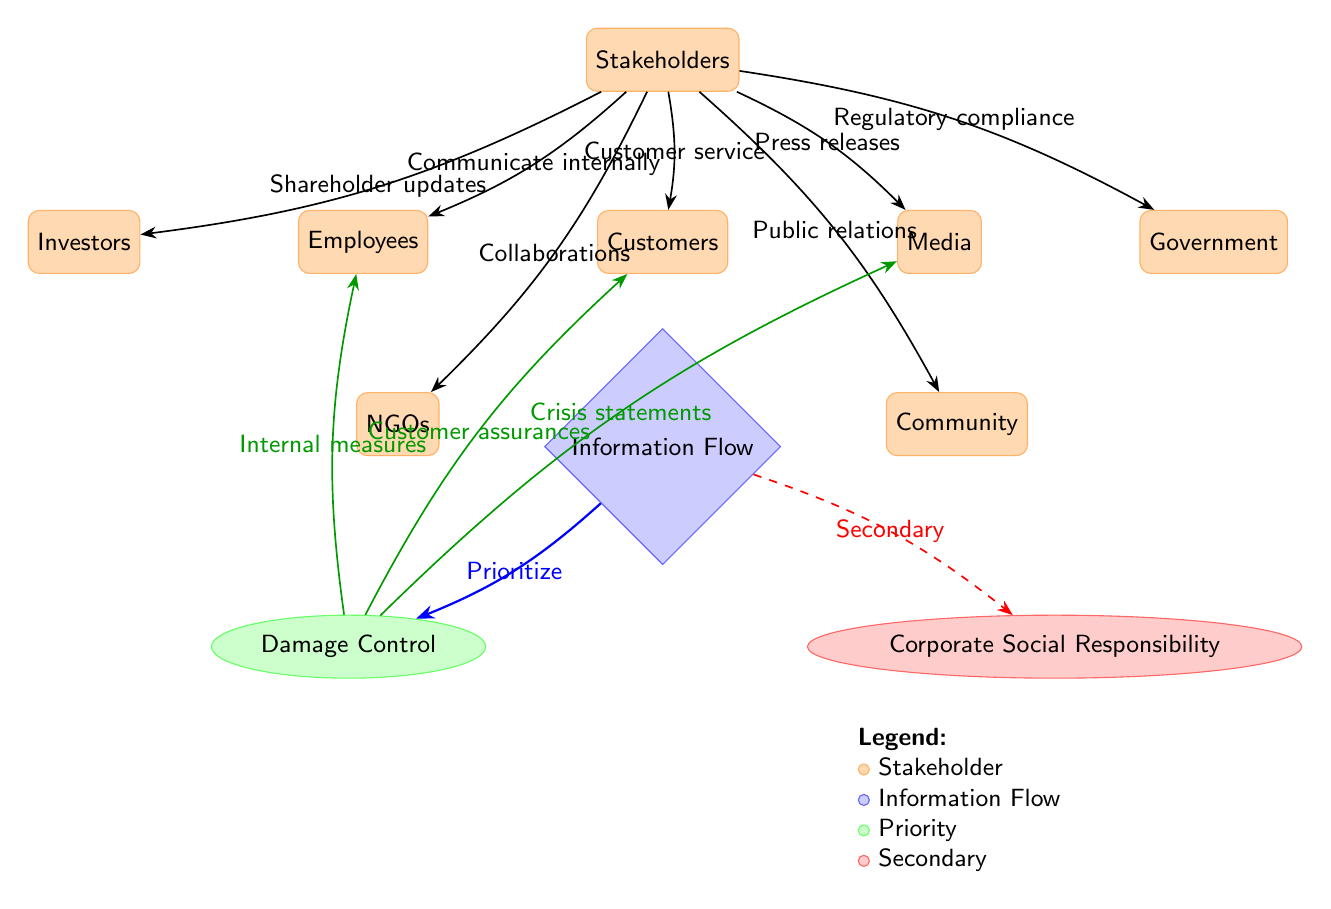What is the primary focus of the information flow in the diagram? The primary focus of the information flow is indicated by the thick blue edge leading to "Damage Control." This shows that the first priority during crisis communication is to manage and contain damage.
Answer: Damage Control Which stakeholder node is connected to the "Media" node? The "Media" node is connected to the "Stakeholders" node through the edge labeled "Press releases," indicating the relationship and communication flow.
Answer: Stakeholders How many stakeholder nodes are present in the diagram? Counting the total number of rectangles representing stakeholders, there are six stakeholder nodes: Employees, Customers, Media, Investors, Government, NGOs, and Community.
Answer: Six What type of communication is indicated for "Customers"? The edge labeled "Customer service" connecting stakeholders to customers indicates the type of communication directed towards them.
Answer: Customer service Which stakeholder node has a dashed connection to "Corporate Social Responsibility"? The connection to "Corporate Social Responsibility" is shown with a dashed edge labeled "Secondary," which indicates that CSR is not the primary focus. The "Stakeholders" node connects to CSR.
Answer: Stakeholders What internal measures are indicated as a priority for "Damage Control"? The edge from "Damage Control" to "Employees" labeled "Internal measures" indicates that addressing employee issues is prioritized in damage control actions during a crisis.
Answer: Internal measures What does the arrow labeled "Collaborations" represent? The arrow labeled "Collaborations" leading from "Stakeholders" to "NGOs" represents the communication and interaction between the organization and non-governmental organizations as part of the stakeholder management.
Answer: Collaborations How many nodes are there in total for information flow? There are three nodes in the information flow section: "Information Flow," "Damage Control," and "Corporate Social Responsibility," summarizing the core focus areas during a crisis.
Answer: Three Which group is considered a secondary concern in the context of this diagram? The "Corporate Social Responsibility" node is indicated with a dashed edge as a secondary focus compared to "Damage Control," indicating that it is less prioritized during a crisis.
Answer: Corporate Social Responsibility 